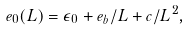Convert formula to latex. <formula><loc_0><loc_0><loc_500><loc_500>e _ { 0 } ( L ) = \epsilon _ { 0 } + e _ { b } / L + c / L ^ { 2 } ,</formula> 